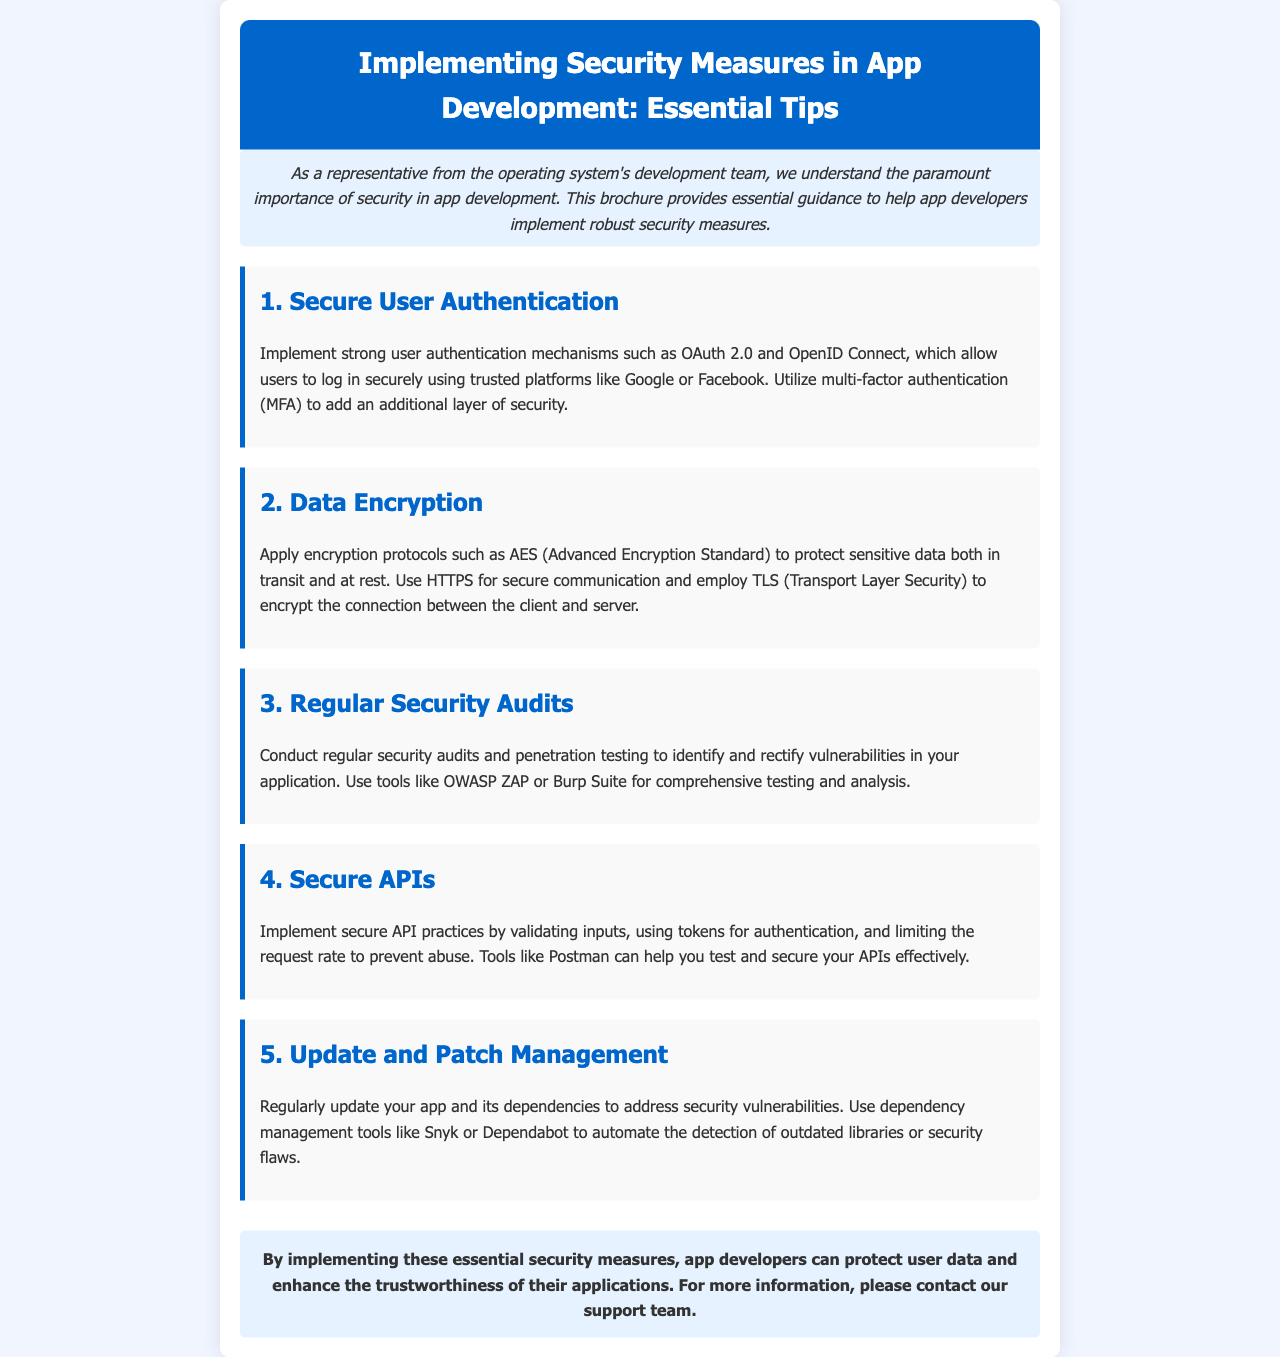What are two strong user authentication mechanisms mentioned? The document lists OAuth 2.0 and OpenID Connect as strong user authentication mechanisms.
Answer: OAuth 2.0, OpenID Connect What encryption protocol is suggested for protecting sensitive data? The brochure recommends using AES (Advanced Encryption Standard) to protect sensitive data.
Answer: AES Which testing tool is mentioned for conducting security audits? The document suggests using OWASP ZAP or Burp Suite for comprehensive testing and analysis during security audits.
Answer: OWASP ZAP, Burp Suite What is the recommended practice for securing APIs? The document advises validating inputs and using tokens for authentication to secure APIs.
Answer: Validating inputs, tokens for authentication How often should apps and dependencies be updated according to the document? The brochure emphasizes the importance of regular updates to address security vulnerabilities.
Answer: Regularly What type of authentication adds an additional layer of security? The document mentions multi-factor authentication (MFA) as an additional layer of security.
Answer: Multi-factor authentication (MFA) What is the color of the header in the brochure? The header's background color is specifically stated to be #0066cc.
Answer: #0066cc In what context is HTTPS mentioned? The document mentions using HTTPS for secure communication, which relates to data encryption.
Answer: Secure communication What is the conclusion's main takeaway for app developers? The main takeaway is that implementing essential security measures can protect user data and enhance trustworthiness.
Answer: Protect user data and enhance trustworthiness 